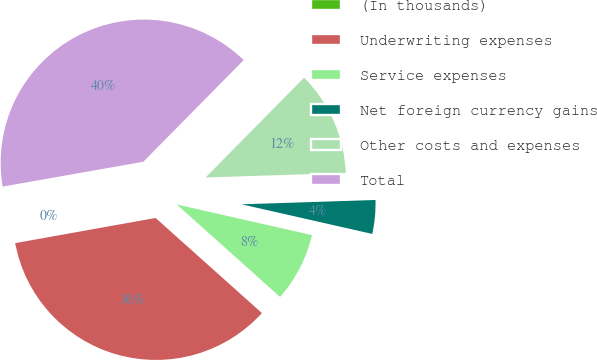Convert chart to OTSL. <chart><loc_0><loc_0><loc_500><loc_500><pie_chart><fcel>(In thousands)<fcel>Underwriting expenses<fcel>Service expenses<fcel>Net foreign currency gains<fcel>Other costs and expenses<fcel>Total<nl><fcel>0.04%<fcel>35.56%<fcel>8.07%<fcel>4.06%<fcel>12.09%<fcel>40.18%<nl></chart> 